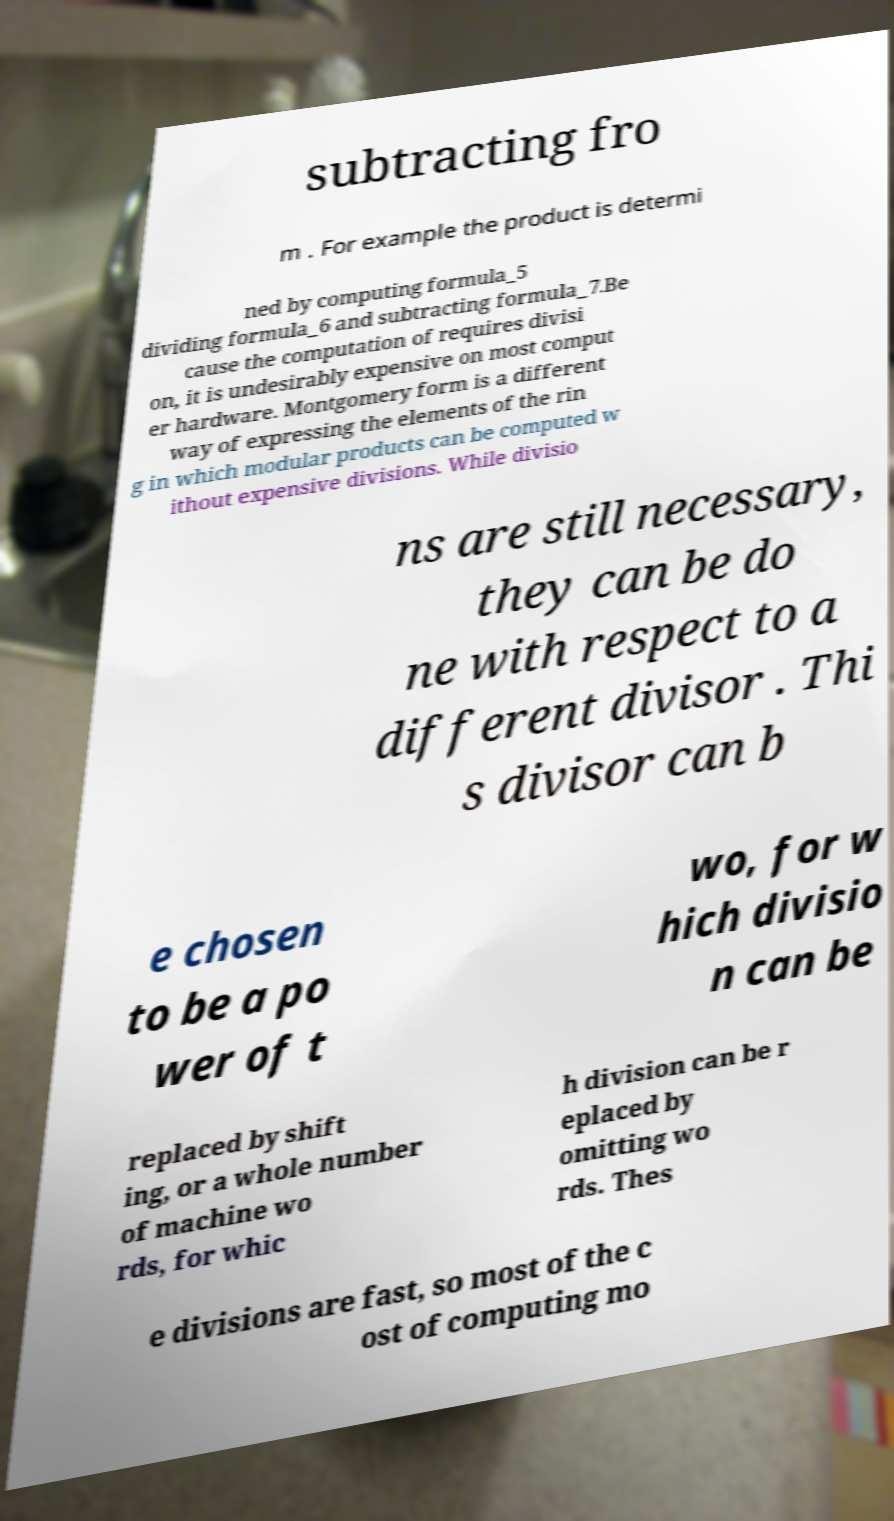Can you accurately transcribe the text from the provided image for me? subtracting fro m . For example the product is determi ned by computing formula_5 dividing formula_6 and subtracting formula_7.Be cause the computation of requires divisi on, it is undesirably expensive on most comput er hardware. Montgomery form is a different way of expressing the elements of the rin g in which modular products can be computed w ithout expensive divisions. While divisio ns are still necessary, they can be do ne with respect to a different divisor . Thi s divisor can b e chosen to be a po wer of t wo, for w hich divisio n can be replaced by shift ing, or a whole number of machine wo rds, for whic h division can be r eplaced by omitting wo rds. Thes e divisions are fast, so most of the c ost of computing mo 